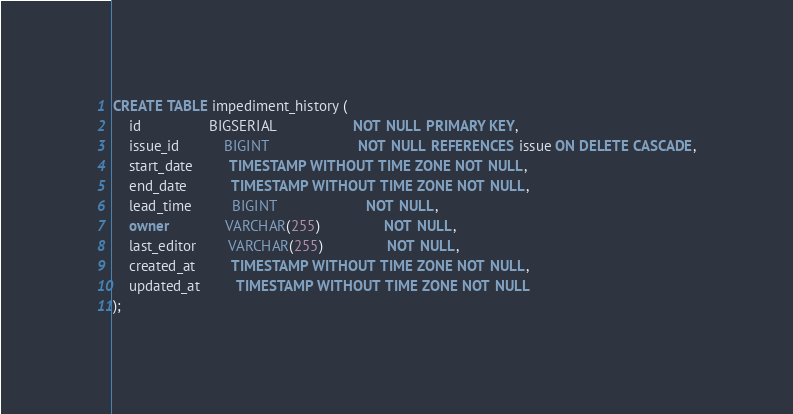Convert code to text. <code><loc_0><loc_0><loc_500><loc_500><_SQL_>CREATE TABLE impediment_history (
    id                 BIGSERIAL                   NOT NULL PRIMARY KEY,
    issue_id           BIGINT                      NOT NULL REFERENCES issue ON DELETE CASCADE,
    start_date         TIMESTAMP WITHOUT TIME ZONE NOT NULL,
    end_date           TIMESTAMP WITHOUT TIME ZONE NOT NULL,
    lead_time          BIGINT                      NOT NULL,
    owner              VARCHAR(255)                NOT NULL,
    last_editor        VARCHAR(255)                NOT NULL,
    created_at         TIMESTAMP WITHOUT TIME ZONE NOT NULL,
    updated_at         TIMESTAMP WITHOUT TIME ZONE NOT NULL
);
</code> 